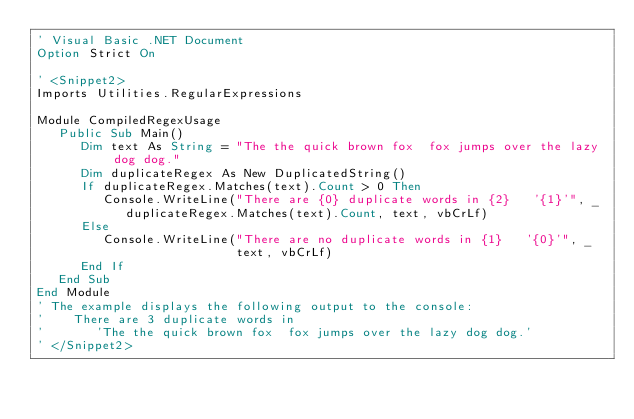Convert code to text. <code><loc_0><loc_0><loc_500><loc_500><_VisualBasic_>' Visual Basic .NET Document
Option Strict On

' <Snippet2>
Imports Utilities.RegularExpressions

Module CompiledRegexUsage
   Public Sub Main()
      Dim text As String = "The the quick brown fox  fox jumps over the lazy dog dog."
      Dim duplicateRegex As New DuplicatedString()
      If duplicateRegex.Matches(text).Count > 0 Then
         Console.WriteLine("There are {0} duplicate words in {2}   '{1}'", _
            duplicateRegex.Matches(text).Count, text, vbCrLf)
      Else
         Console.WriteLine("There are no duplicate words in {1}   '{0}'", _
                           text, vbCrLf)
      End If
   End Sub
End Module
' The example displays the following output to the console:
'    There are 3 duplicate words in
'       'The the quick brown fox  fox jumps over the lazy dog dog.'
' </Snippet2>

</code> 